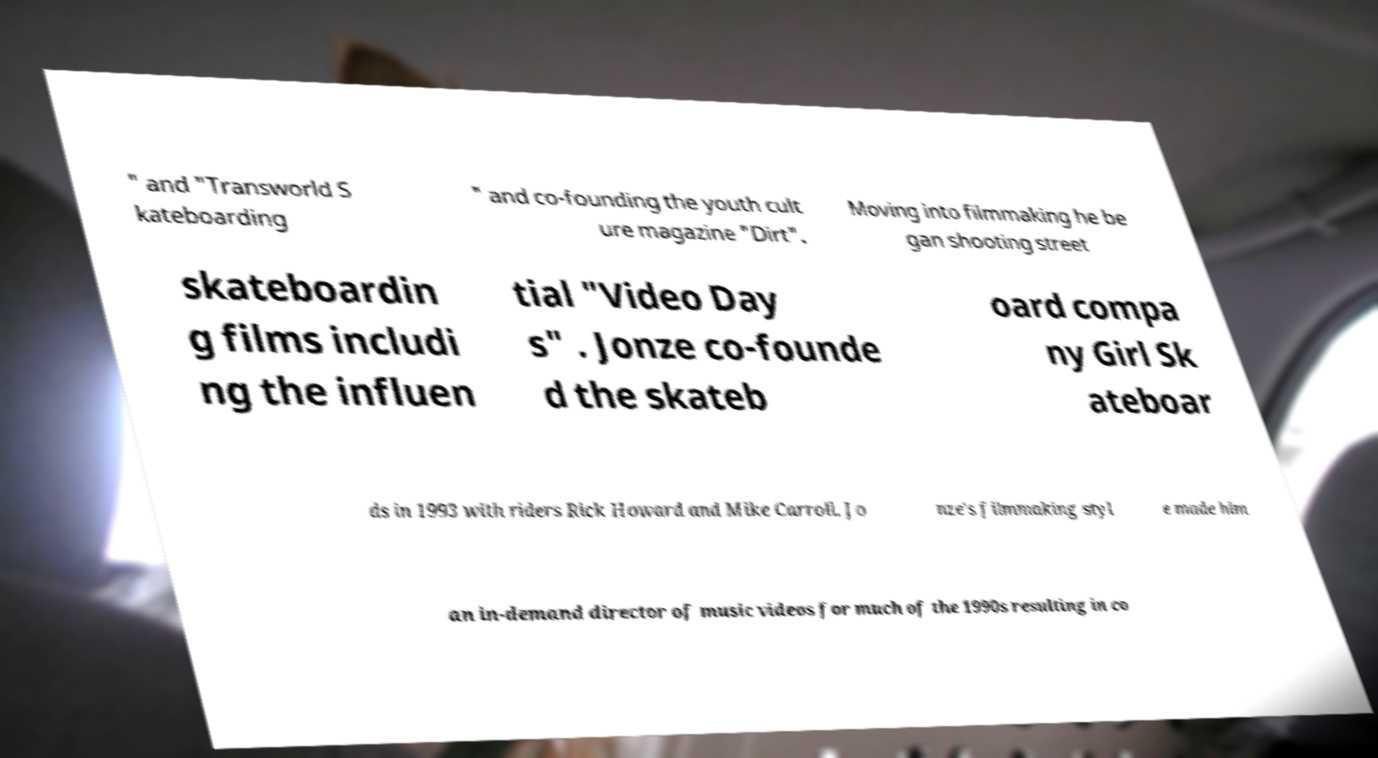For documentation purposes, I need the text within this image transcribed. Could you provide that? " and "Transworld S kateboarding " and co-founding the youth cult ure magazine "Dirt". Moving into filmmaking he be gan shooting street skateboardin g films includi ng the influen tial "Video Day s" . Jonze co-founde d the skateb oard compa ny Girl Sk ateboar ds in 1993 with riders Rick Howard and Mike Carroll. Jo nze's filmmaking styl e made him an in-demand director of music videos for much of the 1990s resulting in co 